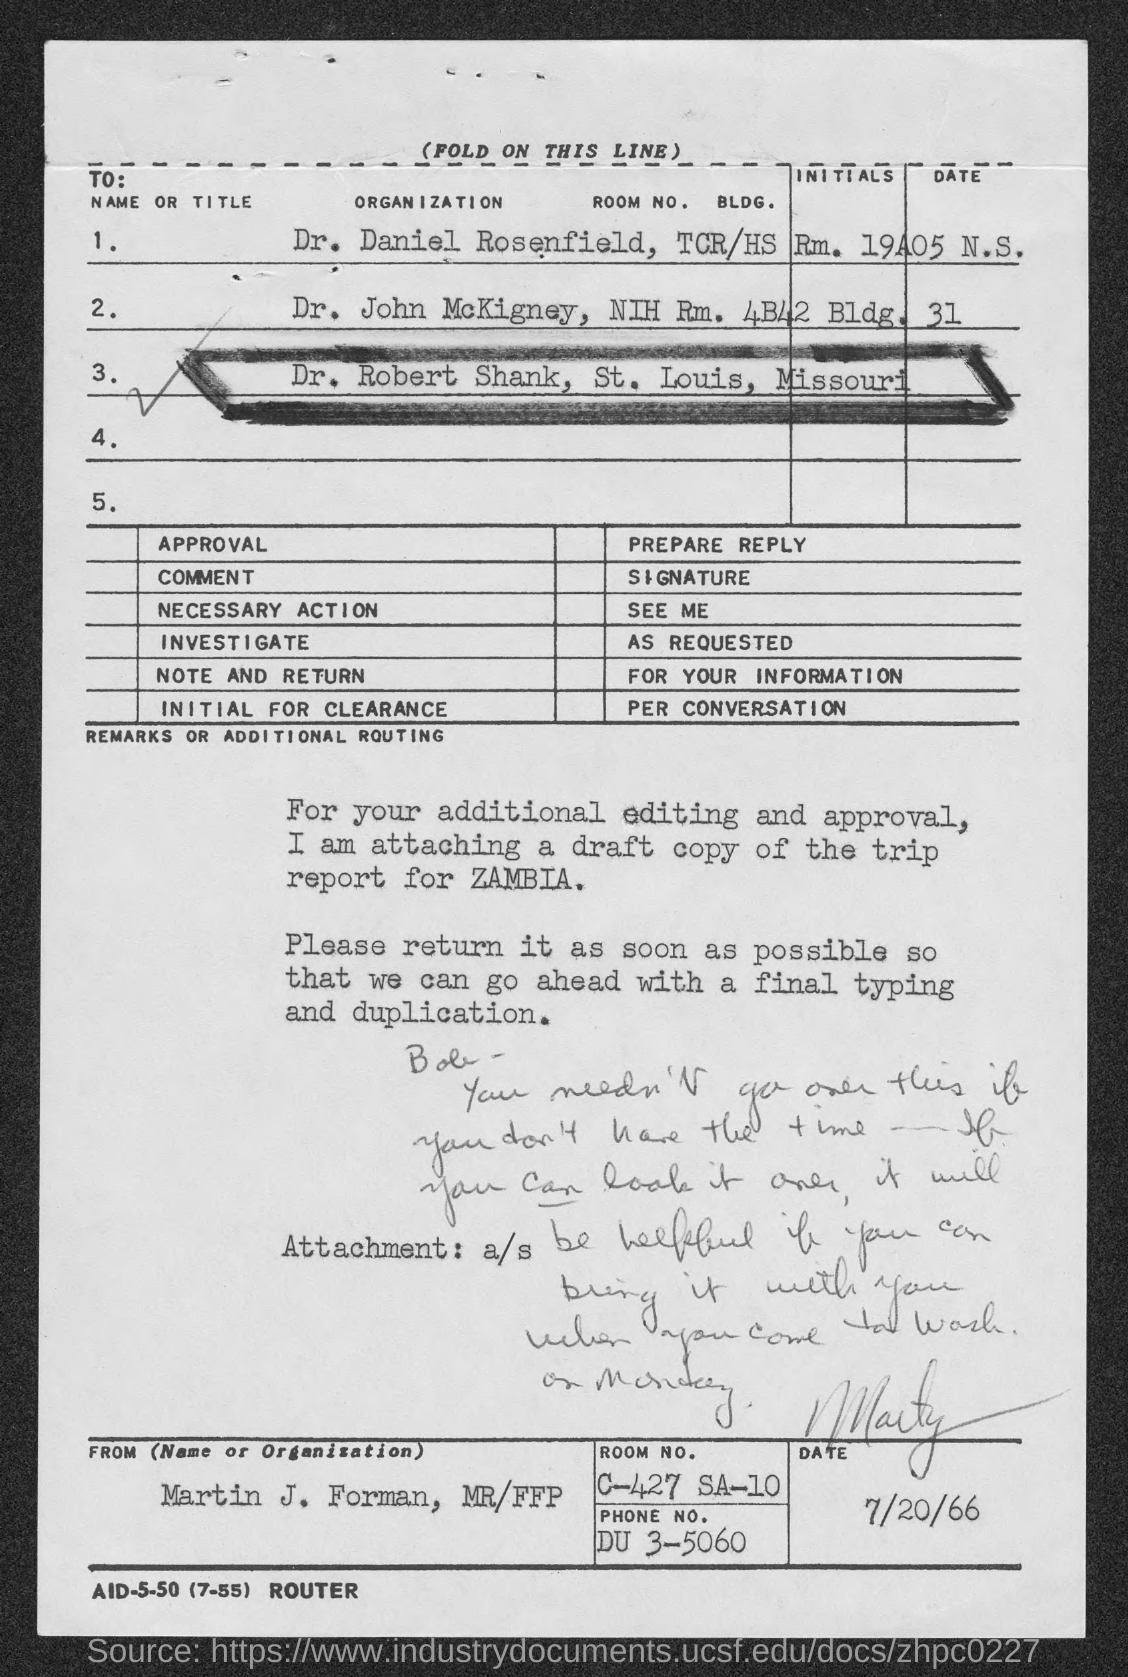Who is the sender of this document?
Your answer should be very brief. MARTIN J. FORMAN. What is the Room No. of Martin J. Forman, MR/FFP?
Keep it short and to the point. C-427 SA-10. What is the phone no. of Martin J. Forman, MR/FFP?
Offer a terse response. DU 3-5060. 